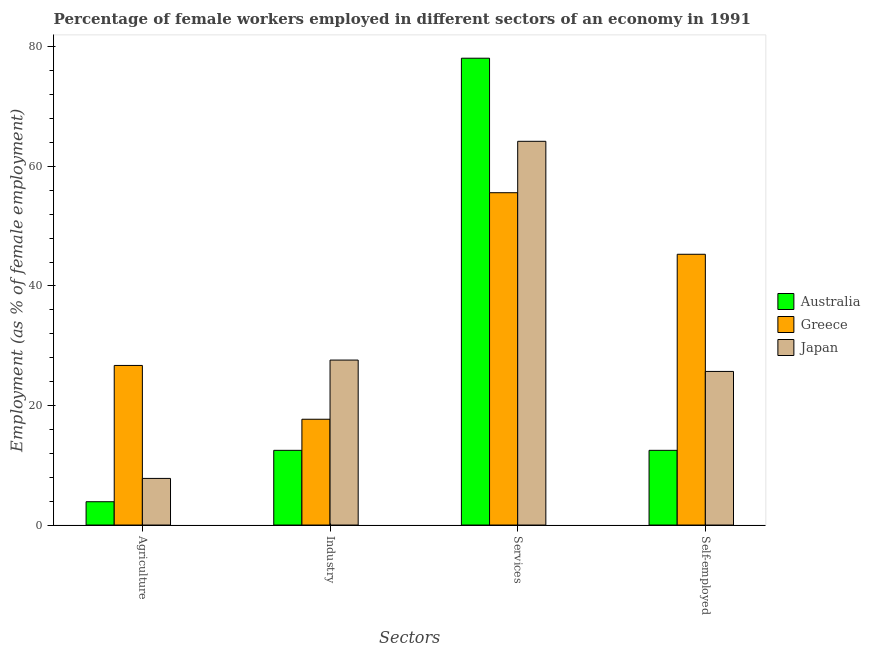How many different coloured bars are there?
Your response must be concise. 3. How many groups of bars are there?
Provide a succinct answer. 4. How many bars are there on the 4th tick from the right?
Give a very brief answer. 3. What is the label of the 3rd group of bars from the left?
Your response must be concise. Services. What is the percentage of self employed female workers in Greece?
Ensure brevity in your answer.  45.3. Across all countries, what is the maximum percentage of female workers in services?
Your answer should be compact. 78.1. Across all countries, what is the minimum percentage of female workers in agriculture?
Give a very brief answer. 3.9. What is the total percentage of female workers in agriculture in the graph?
Offer a terse response. 38.4. What is the difference between the percentage of female workers in agriculture in Greece and that in Japan?
Your response must be concise. 18.9. What is the difference between the percentage of female workers in services in Greece and the percentage of female workers in agriculture in Australia?
Provide a succinct answer. 51.7. What is the average percentage of female workers in agriculture per country?
Offer a terse response. 12.8. What is the difference between the percentage of self employed female workers and percentage of female workers in agriculture in Australia?
Provide a short and direct response. 8.6. What is the ratio of the percentage of self employed female workers in Greece to that in Japan?
Make the answer very short. 1.76. What is the difference between the highest and the second highest percentage of female workers in services?
Ensure brevity in your answer.  13.9. What is the difference between the highest and the lowest percentage of female workers in agriculture?
Your answer should be compact. 22.8. In how many countries, is the percentage of female workers in agriculture greater than the average percentage of female workers in agriculture taken over all countries?
Provide a succinct answer. 1. Is the sum of the percentage of female workers in agriculture in Greece and Japan greater than the maximum percentage of self employed female workers across all countries?
Your answer should be very brief. No. Is it the case that in every country, the sum of the percentage of female workers in agriculture and percentage of female workers in industry is greater than the percentage of female workers in services?
Your response must be concise. No. How many bars are there?
Your response must be concise. 12. Are all the bars in the graph horizontal?
Provide a succinct answer. No. Are the values on the major ticks of Y-axis written in scientific E-notation?
Your answer should be very brief. No. Does the graph contain any zero values?
Provide a short and direct response. No. Does the graph contain grids?
Your answer should be compact. No. What is the title of the graph?
Your answer should be very brief. Percentage of female workers employed in different sectors of an economy in 1991. What is the label or title of the X-axis?
Make the answer very short. Sectors. What is the label or title of the Y-axis?
Offer a terse response. Employment (as % of female employment). What is the Employment (as % of female employment) in Australia in Agriculture?
Make the answer very short. 3.9. What is the Employment (as % of female employment) in Greece in Agriculture?
Offer a very short reply. 26.7. What is the Employment (as % of female employment) in Japan in Agriculture?
Your answer should be very brief. 7.8. What is the Employment (as % of female employment) of Greece in Industry?
Make the answer very short. 17.7. What is the Employment (as % of female employment) in Japan in Industry?
Your response must be concise. 27.6. What is the Employment (as % of female employment) of Australia in Services?
Your answer should be very brief. 78.1. What is the Employment (as % of female employment) in Greece in Services?
Your answer should be very brief. 55.6. What is the Employment (as % of female employment) in Japan in Services?
Make the answer very short. 64.2. What is the Employment (as % of female employment) of Australia in Self-employed?
Offer a terse response. 12.5. What is the Employment (as % of female employment) in Greece in Self-employed?
Offer a terse response. 45.3. What is the Employment (as % of female employment) in Japan in Self-employed?
Provide a short and direct response. 25.7. Across all Sectors, what is the maximum Employment (as % of female employment) of Australia?
Provide a short and direct response. 78.1. Across all Sectors, what is the maximum Employment (as % of female employment) of Greece?
Offer a terse response. 55.6. Across all Sectors, what is the maximum Employment (as % of female employment) of Japan?
Provide a short and direct response. 64.2. Across all Sectors, what is the minimum Employment (as % of female employment) in Australia?
Provide a short and direct response. 3.9. Across all Sectors, what is the minimum Employment (as % of female employment) in Greece?
Provide a short and direct response. 17.7. Across all Sectors, what is the minimum Employment (as % of female employment) in Japan?
Give a very brief answer. 7.8. What is the total Employment (as % of female employment) in Australia in the graph?
Provide a short and direct response. 107. What is the total Employment (as % of female employment) of Greece in the graph?
Offer a terse response. 145.3. What is the total Employment (as % of female employment) in Japan in the graph?
Ensure brevity in your answer.  125.3. What is the difference between the Employment (as % of female employment) in Japan in Agriculture and that in Industry?
Your answer should be very brief. -19.8. What is the difference between the Employment (as % of female employment) in Australia in Agriculture and that in Services?
Ensure brevity in your answer.  -74.2. What is the difference between the Employment (as % of female employment) in Greece in Agriculture and that in Services?
Make the answer very short. -28.9. What is the difference between the Employment (as % of female employment) of Japan in Agriculture and that in Services?
Provide a short and direct response. -56.4. What is the difference between the Employment (as % of female employment) in Australia in Agriculture and that in Self-employed?
Provide a short and direct response. -8.6. What is the difference between the Employment (as % of female employment) of Greece in Agriculture and that in Self-employed?
Keep it short and to the point. -18.6. What is the difference between the Employment (as % of female employment) of Japan in Agriculture and that in Self-employed?
Ensure brevity in your answer.  -17.9. What is the difference between the Employment (as % of female employment) in Australia in Industry and that in Services?
Your answer should be compact. -65.6. What is the difference between the Employment (as % of female employment) in Greece in Industry and that in Services?
Offer a very short reply. -37.9. What is the difference between the Employment (as % of female employment) in Japan in Industry and that in Services?
Keep it short and to the point. -36.6. What is the difference between the Employment (as % of female employment) in Greece in Industry and that in Self-employed?
Provide a short and direct response. -27.6. What is the difference between the Employment (as % of female employment) of Japan in Industry and that in Self-employed?
Your answer should be compact. 1.9. What is the difference between the Employment (as % of female employment) of Australia in Services and that in Self-employed?
Make the answer very short. 65.6. What is the difference between the Employment (as % of female employment) of Greece in Services and that in Self-employed?
Your answer should be compact. 10.3. What is the difference between the Employment (as % of female employment) in Japan in Services and that in Self-employed?
Your response must be concise. 38.5. What is the difference between the Employment (as % of female employment) of Australia in Agriculture and the Employment (as % of female employment) of Greece in Industry?
Offer a terse response. -13.8. What is the difference between the Employment (as % of female employment) in Australia in Agriculture and the Employment (as % of female employment) in Japan in Industry?
Offer a terse response. -23.7. What is the difference between the Employment (as % of female employment) of Greece in Agriculture and the Employment (as % of female employment) of Japan in Industry?
Your response must be concise. -0.9. What is the difference between the Employment (as % of female employment) in Australia in Agriculture and the Employment (as % of female employment) in Greece in Services?
Your answer should be compact. -51.7. What is the difference between the Employment (as % of female employment) of Australia in Agriculture and the Employment (as % of female employment) of Japan in Services?
Offer a terse response. -60.3. What is the difference between the Employment (as % of female employment) of Greece in Agriculture and the Employment (as % of female employment) of Japan in Services?
Make the answer very short. -37.5. What is the difference between the Employment (as % of female employment) in Australia in Agriculture and the Employment (as % of female employment) in Greece in Self-employed?
Your answer should be very brief. -41.4. What is the difference between the Employment (as % of female employment) in Australia in Agriculture and the Employment (as % of female employment) in Japan in Self-employed?
Provide a succinct answer. -21.8. What is the difference between the Employment (as % of female employment) of Greece in Agriculture and the Employment (as % of female employment) of Japan in Self-employed?
Ensure brevity in your answer.  1. What is the difference between the Employment (as % of female employment) in Australia in Industry and the Employment (as % of female employment) in Greece in Services?
Your answer should be very brief. -43.1. What is the difference between the Employment (as % of female employment) in Australia in Industry and the Employment (as % of female employment) in Japan in Services?
Your response must be concise. -51.7. What is the difference between the Employment (as % of female employment) of Greece in Industry and the Employment (as % of female employment) of Japan in Services?
Your response must be concise. -46.5. What is the difference between the Employment (as % of female employment) in Australia in Industry and the Employment (as % of female employment) in Greece in Self-employed?
Your answer should be compact. -32.8. What is the difference between the Employment (as % of female employment) in Australia in Services and the Employment (as % of female employment) in Greece in Self-employed?
Your response must be concise. 32.8. What is the difference between the Employment (as % of female employment) in Australia in Services and the Employment (as % of female employment) in Japan in Self-employed?
Provide a succinct answer. 52.4. What is the difference between the Employment (as % of female employment) in Greece in Services and the Employment (as % of female employment) in Japan in Self-employed?
Your answer should be very brief. 29.9. What is the average Employment (as % of female employment) in Australia per Sectors?
Your answer should be very brief. 26.75. What is the average Employment (as % of female employment) in Greece per Sectors?
Give a very brief answer. 36.33. What is the average Employment (as % of female employment) in Japan per Sectors?
Your answer should be compact. 31.32. What is the difference between the Employment (as % of female employment) of Australia and Employment (as % of female employment) of Greece in Agriculture?
Provide a succinct answer. -22.8. What is the difference between the Employment (as % of female employment) of Australia and Employment (as % of female employment) of Greece in Industry?
Your response must be concise. -5.2. What is the difference between the Employment (as % of female employment) of Australia and Employment (as % of female employment) of Japan in Industry?
Provide a short and direct response. -15.1. What is the difference between the Employment (as % of female employment) in Greece and Employment (as % of female employment) in Japan in Industry?
Provide a succinct answer. -9.9. What is the difference between the Employment (as % of female employment) of Australia and Employment (as % of female employment) of Greece in Self-employed?
Your response must be concise. -32.8. What is the difference between the Employment (as % of female employment) in Greece and Employment (as % of female employment) in Japan in Self-employed?
Provide a succinct answer. 19.6. What is the ratio of the Employment (as % of female employment) in Australia in Agriculture to that in Industry?
Your answer should be very brief. 0.31. What is the ratio of the Employment (as % of female employment) of Greece in Agriculture to that in Industry?
Provide a short and direct response. 1.51. What is the ratio of the Employment (as % of female employment) in Japan in Agriculture to that in Industry?
Your response must be concise. 0.28. What is the ratio of the Employment (as % of female employment) in Australia in Agriculture to that in Services?
Ensure brevity in your answer.  0.05. What is the ratio of the Employment (as % of female employment) of Greece in Agriculture to that in Services?
Your response must be concise. 0.48. What is the ratio of the Employment (as % of female employment) in Japan in Agriculture to that in Services?
Ensure brevity in your answer.  0.12. What is the ratio of the Employment (as % of female employment) in Australia in Agriculture to that in Self-employed?
Your response must be concise. 0.31. What is the ratio of the Employment (as % of female employment) in Greece in Agriculture to that in Self-employed?
Make the answer very short. 0.59. What is the ratio of the Employment (as % of female employment) in Japan in Agriculture to that in Self-employed?
Your answer should be compact. 0.3. What is the ratio of the Employment (as % of female employment) in Australia in Industry to that in Services?
Provide a short and direct response. 0.16. What is the ratio of the Employment (as % of female employment) in Greece in Industry to that in Services?
Keep it short and to the point. 0.32. What is the ratio of the Employment (as % of female employment) in Japan in Industry to that in Services?
Keep it short and to the point. 0.43. What is the ratio of the Employment (as % of female employment) of Australia in Industry to that in Self-employed?
Ensure brevity in your answer.  1. What is the ratio of the Employment (as % of female employment) in Greece in Industry to that in Self-employed?
Keep it short and to the point. 0.39. What is the ratio of the Employment (as % of female employment) in Japan in Industry to that in Self-employed?
Your response must be concise. 1.07. What is the ratio of the Employment (as % of female employment) in Australia in Services to that in Self-employed?
Your answer should be compact. 6.25. What is the ratio of the Employment (as % of female employment) in Greece in Services to that in Self-employed?
Your response must be concise. 1.23. What is the ratio of the Employment (as % of female employment) in Japan in Services to that in Self-employed?
Provide a succinct answer. 2.5. What is the difference between the highest and the second highest Employment (as % of female employment) in Australia?
Provide a short and direct response. 65.6. What is the difference between the highest and the second highest Employment (as % of female employment) in Japan?
Ensure brevity in your answer.  36.6. What is the difference between the highest and the lowest Employment (as % of female employment) of Australia?
Offer a terse response. 74.2. What is the difference between the highest and the lowest Employment (as % of female employment) of Greece?
Provide a succinct answer. 37.9. What is the difference between the highest and the lowest Employment (as % of female employment) in Japan?
Offer a very short reply. 56.4. 